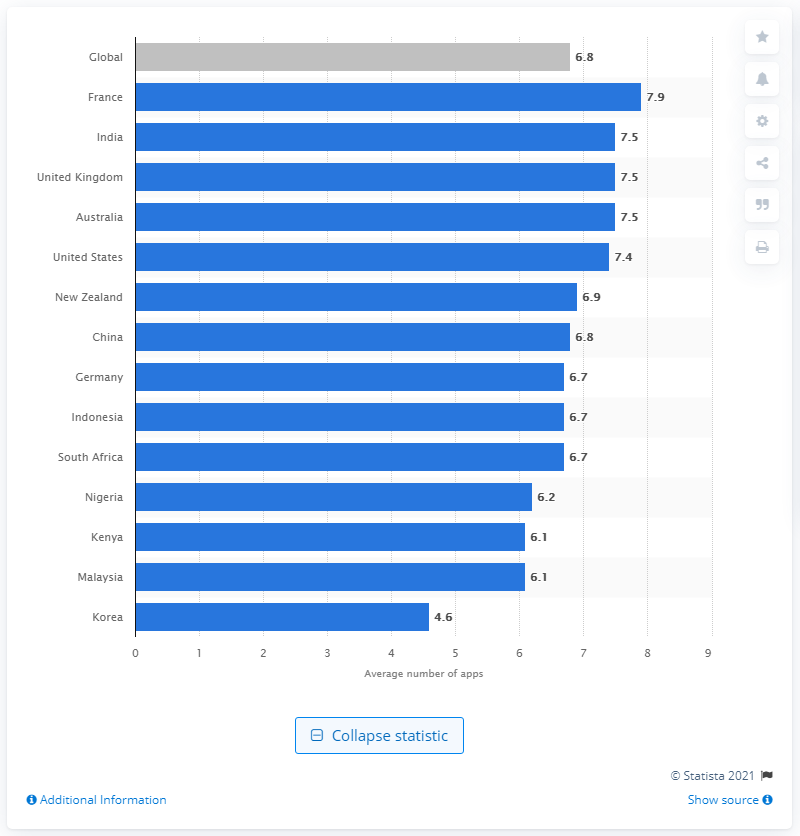Give some essential details in this illustration. In France, the average monthly usage of mobile apps was 7.9... 